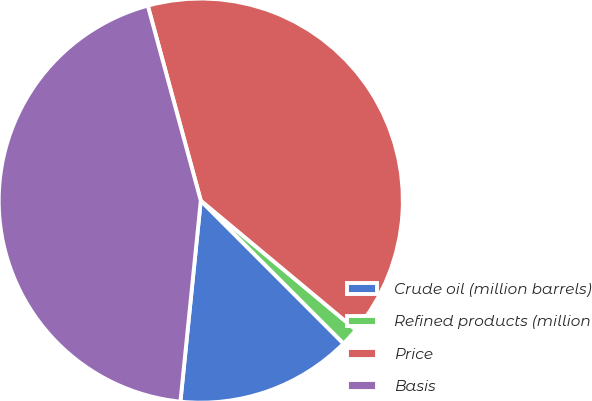Convert chart. <chart><loc_0><loc_0><loc_500><loc_500><pie_chart><fcel>Crude oil (million barrels)<fcel>Refined products (million<fcel>Price<fcel>Basis<nl><fcel>14.1%<fcel>1.45%<fcel>40.28%<fcel>44.17%<nl></chart> 